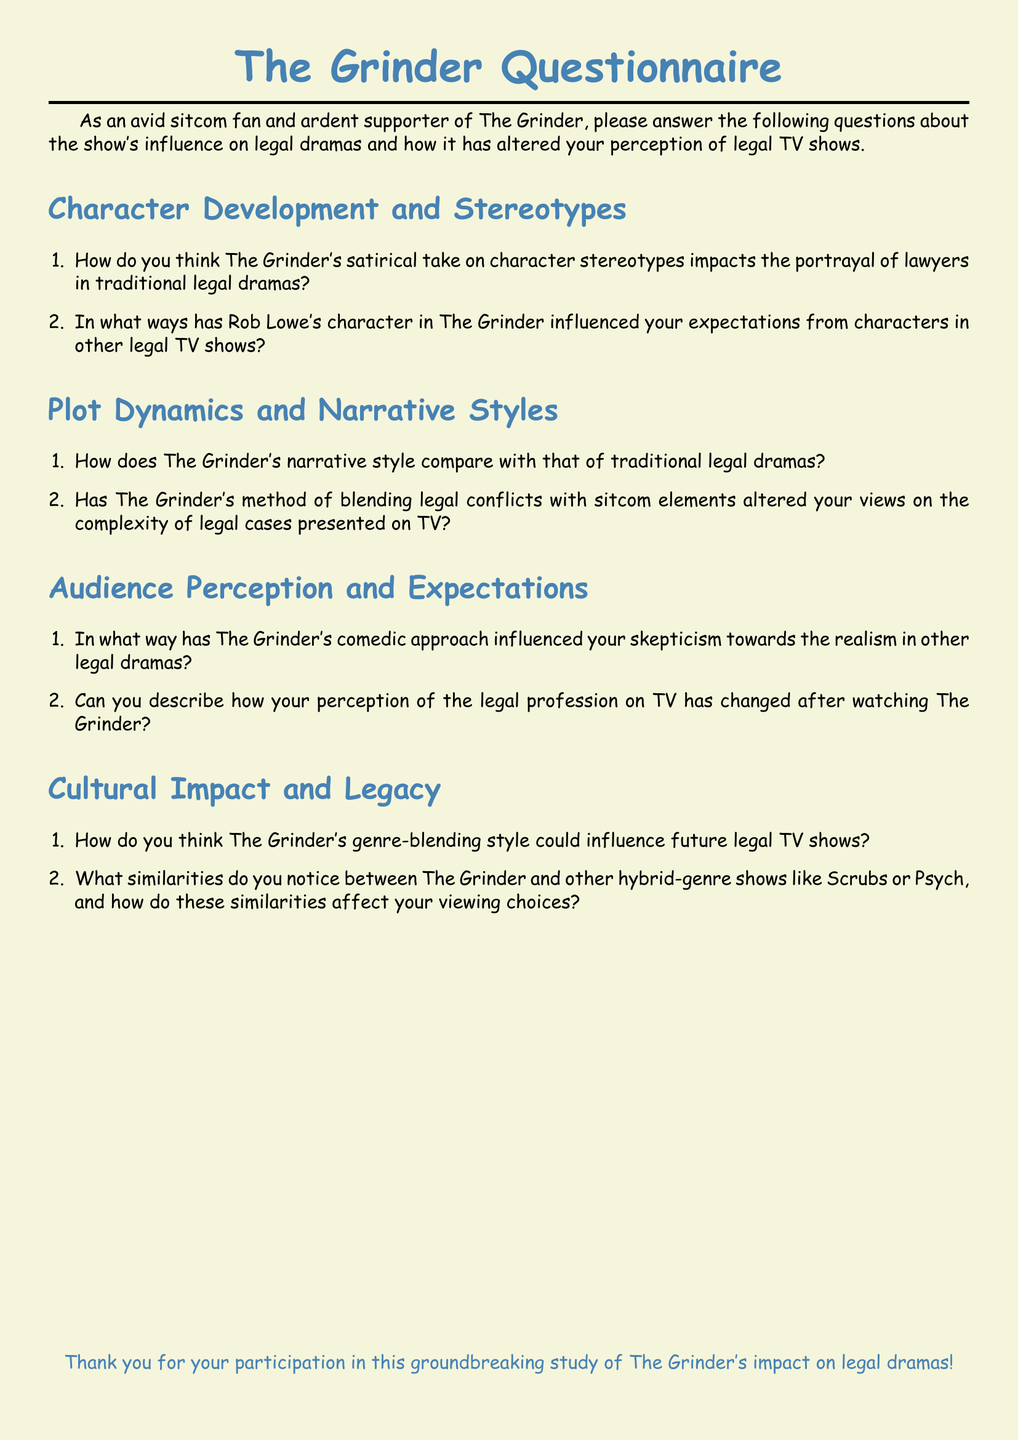What is the main theme of the questionnaire? The main theme of the questionnaire is The Grinder's influence on legal dramas and perceptions of legal TV shows.
Answer: The Grinder's influence on legal dramas How many sections are there in the questionnaire? The sections include Character Development and Stereotypes, Plot Dynamics and Narrative Styles, Audience Perception and Expectations, and Cultural Impact and Legacy, totaling four sections.
Answer: Four Who is the main actor referenced in the questionnaire? The main actor referenced is Rob Lowe, who plays a character in The Grinder.
Answer: Rob Lowe What color is the document background? The document background color is beige.
Answer: Beige What style of humor does The Grinder primarily use? The Grinder primarily uses a satirical comedic approach to humor.
Answer: Satirical comedic approach Which other hybrid-genre shows are compared to The Grinder in the questionnaire? The hybrid-genre shows compared are Scrubs and Psych.
Answer: Scrubs and Psych What is the significance of The Grinder's genre-blending style mentioned in the document? The significance is its potential to influence future legal TV shows.
Answer: Influence future legal TV shows What font is used in the document? The font used in the document is Comic Sans MS.
Answer: Comic Sans MS How does The Grinder influence audience skepticism towards other legal dramas? The comedic approach of The Grinder influences skepticism towards the realism in other legal dramas.
Answer: Influences skepticism towards realism 